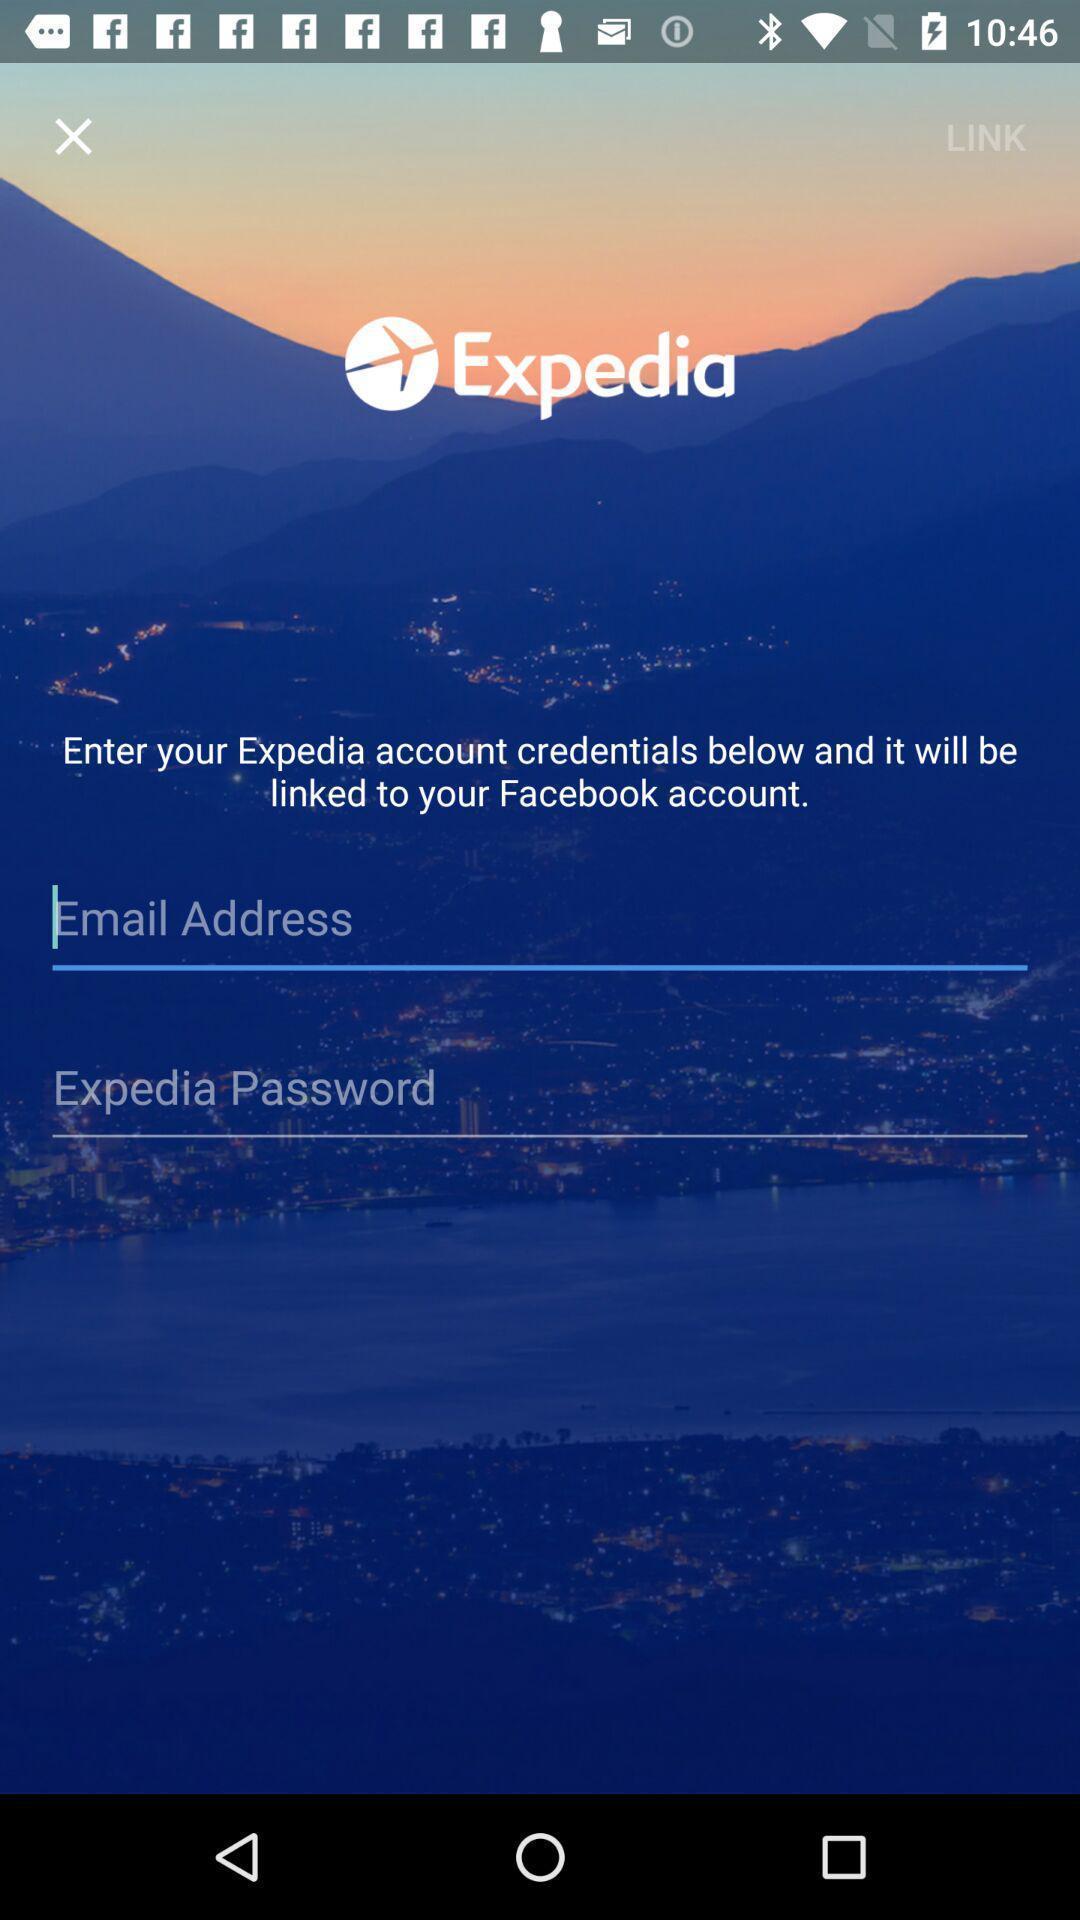Provide a textual representation of this image. Screen displaying the page asking to enter the credentials. 